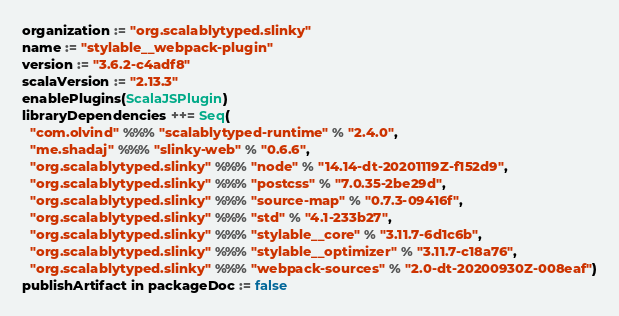<code> <loc_0><loc_0><loc_500><loc_500><_Scala_>organization := "org.scalablytyped.slinky"
name := "stylable__webpack-plugin"
version := "3.6.2-c4adf8"
scalaVersion := "2.13.3"
enablePlugins(ScalaJSPlugin)
libraryDependencies ++= Seq(
  "com.olvind" %%% "scalablytyped-runtime" % "2.4.0",
  "me.shadaj" %%% "slinky-web" % "0.6.6",
  "org.scalablytyped.slinky" %%% "node" % "14.14-dt-20201119Z-f152d9",
  "org.scalablytyped.slinky" %%% "postcss" % "7.0.35-2be29d",
  "org.scalablytyped.slinky" %%% "source-map" % "0.7.3-09416f",
  "org.scalablytyped.slinky" %%% "std" % "4.1-233b27",
  "org.scalablytyped.slinky" %%% "stylable__core" % "3.11.7-6d1c6b",
  "org.scalablytyped.slinky" %%% "stylable__optimizer" % "3.11.7-c18a76",
  "org.scalablytyped.slinky" %%% "webpack-sources" % "2.0-dt-20200930Z-008eaf")
publishArtifact in packageDoc := false</code> 